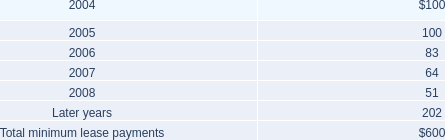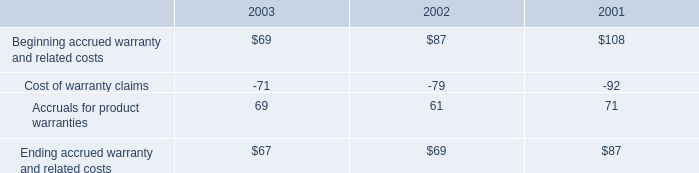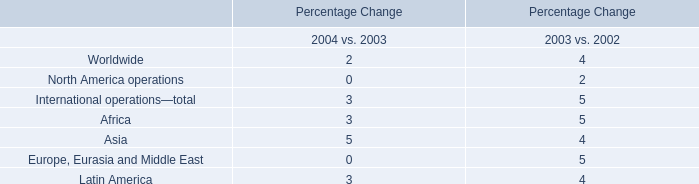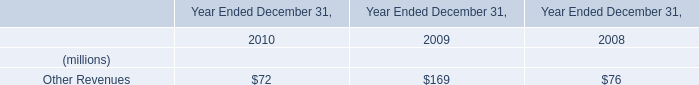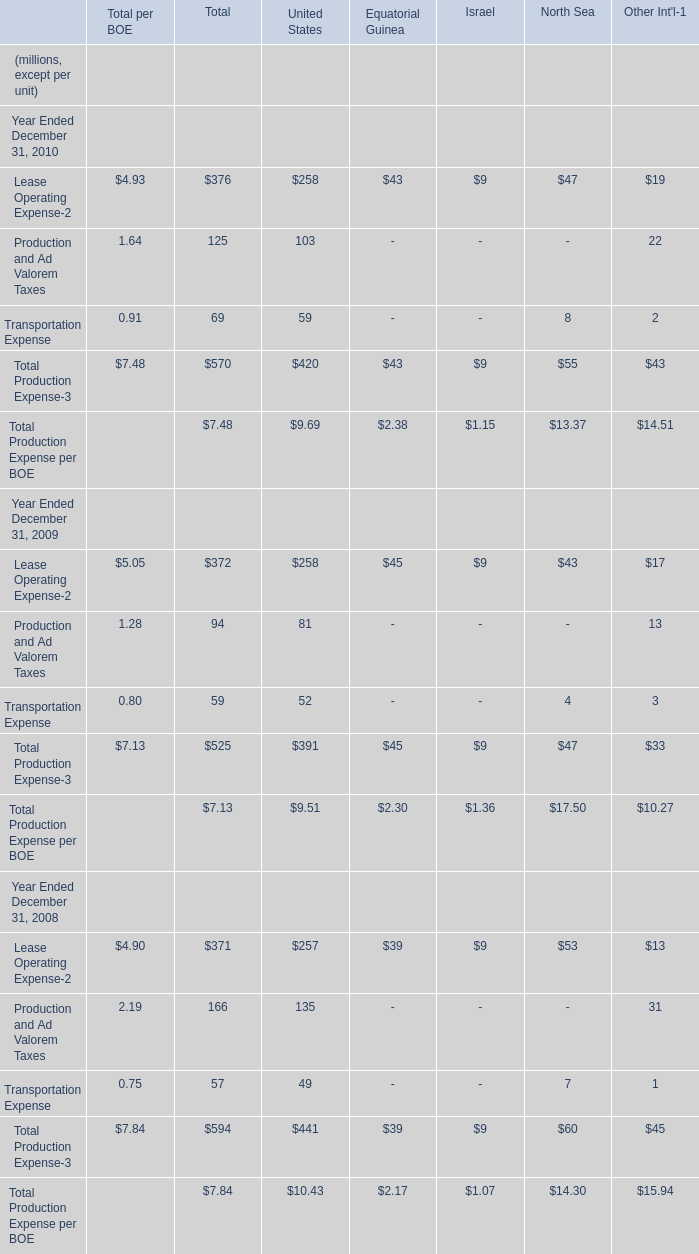Does the value of Lease Operating Expense-2 in 2010 greater than that in 2009 for Total per BOE? 
Answer: no. 